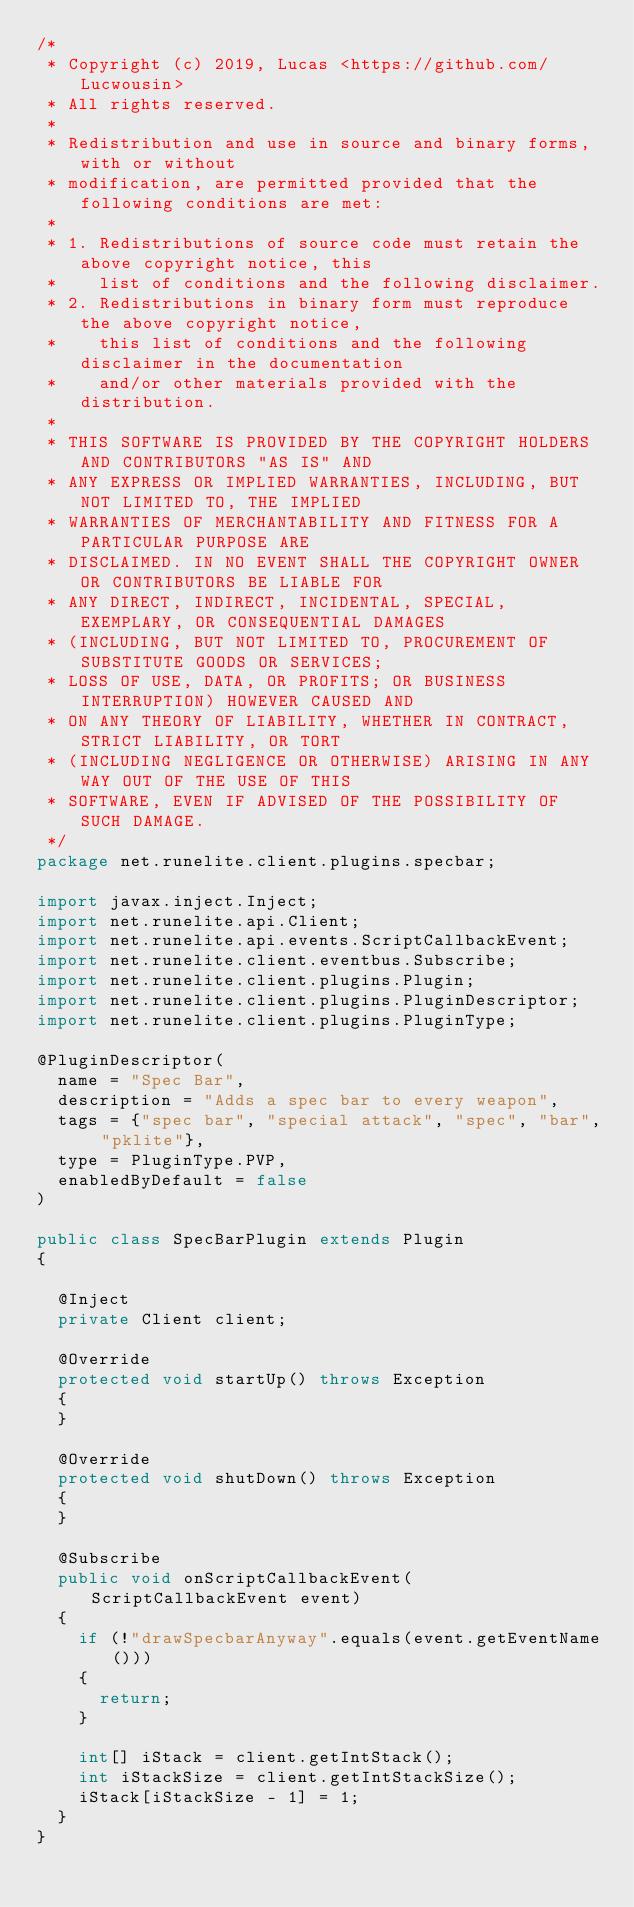<code> <loc_0><loc_0><loc_500><loc_500><_Java_>/*
 * Copyright (c) 2019, Lucas <https://github.com/Lucwousin>
 * All rights reserved.
 *
 * Redistribution and use in source and binary forms, with or without
 * modification, are permitted provided that the following conditions are met:
 *
 * 1. Redistributions of source code must retain the above copyright notice, this
 *    list of conditions and the following disclaimer.
 * 2. Redistributions in binary form must reproduce the above copyright notice,
 *    this list of conditions and the following disclaimer in the documentation
 *    and/or other materials provided with the distribution.
 *
 * THIS SOFTWARE IS PROVIDED BY THE COPYRIGHT HOLDERS AND CONTRIBUTORS "AS IS" AND
 * ANY EXPRESS OR IMPLIED WARRANTIES, INCLUDING, BUT NOT LIMITED TO, THE IMPLIED
 * WARRANTIES OF MERCHANTABILITY AND FITNESS FOR A PARTICULAR PURPOSE ARE
 * DISCLAIMED. IN NO EVENT SHALL THE COPYRIGHT OWNER OR CONTRIBUTORS BE LIABLE FOR
 * ANY DIRECT, INDIRECT, INCIDENTAL, SPECIAL, EXEMPLARY, OR CONSEQUENTIAL DAMAGES
 * (INCLUDING, BUT NOT LIMITED TO, PROCUREMENT OF SUBSTITUTE GOODS OR SERVICES;
 * LOSS OF USE, DATA, OR PROFITS; OR BUSINESS INTERRUPTION) HOWEVER CAUSED AND
 * ON ANY THEORY OF LIABILITY, WHETHER IN CONTRACT, STRICT LIABILITY, OR TORT
 * (INCLUDING NEGLIGENCE OR OTHERWISE) ARISING IN ANY WAY OUT OF THE USE OF THIS
 * SOFTWARE, EVEN IF ADVISED OF THE POSSIBILITY OF SUCH DAMAGE.
 */
package net.runelite.client.plugins.specbar;

import javax.inject.Inject;
import net.runelite.api.Client;
import net.runelite.api.events.ScriptCallbackEvent;
import net.runelite.client.eventbus.Subscribe;
import net.runelite.client.plugins.Plugin;
import net.runelite.client.plugins.PluginDescriptor;
import net.runelite.client.plugins.PluginType;

@PluginDescriptor(
	name = "Spec Bar",
	description = "Adds a spec bar to every weapon",
	tags = {"spec bar", "special attack", "spec", "bar", "pklite"},
	type = PluginType.PVP,
	enabledByDefault = false
)

public class SpecBarPlugin extends Plugin
{

	@Inject
	private Client client;

	@Override
	protected void startUp() throws Exception
	{
	}

	@Override
	protected void shutDown() throws Exception
	{
	}

	@Subscribe
	public void onScriptCallbackEvent(ScriptCallbackEvent event)
	{
		if (!"drawSpecbarAnyway".equals(event.getEventName()))
		{
			return;
		}

		int[] iStack = client.getIntStack();
		int iStackSize = client.getIntStackSize();
		iStack[iStackSize - 1] = 1;
	}
}
</code> 